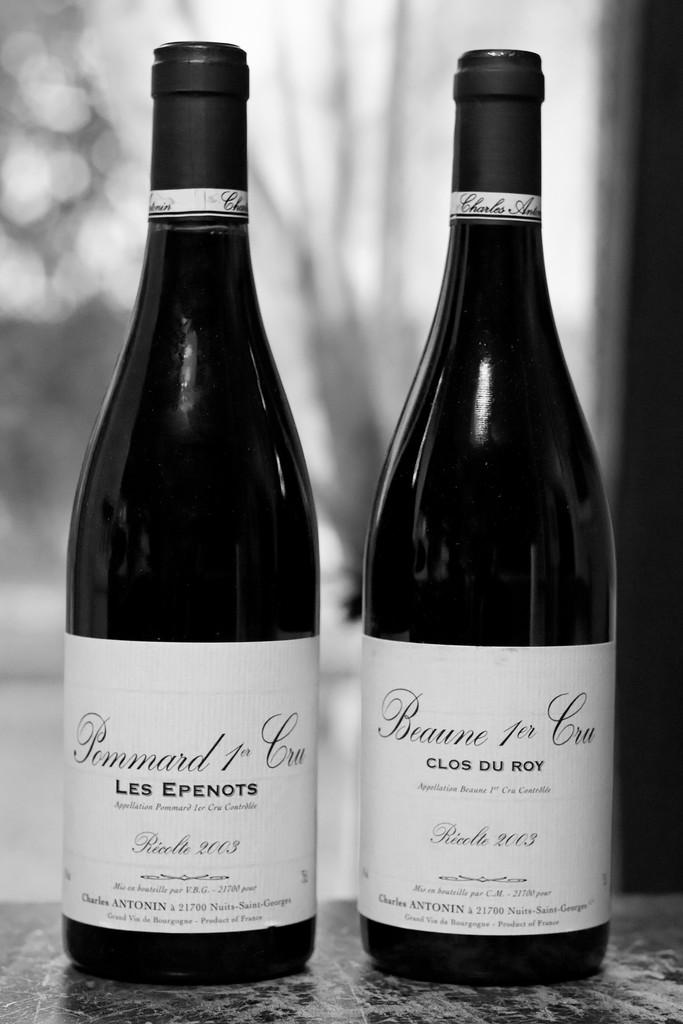<image>
Present a compact description of the photo's key features. Two bottles with one that has a white label saying "Clos Du Roy". 